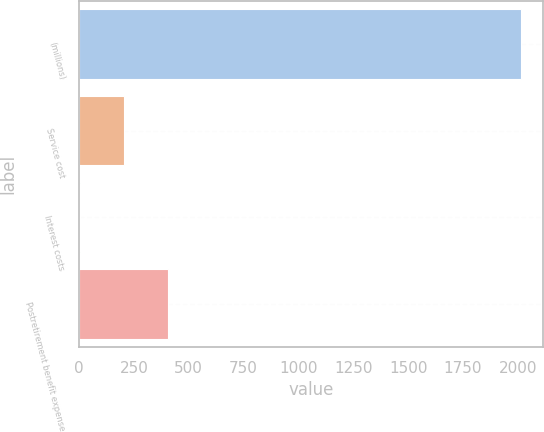<chart> <loc_0><loc_0><loc_500><loc_500><bar_chart><fcel>(millions)<fcel>Service cost<fcel>Interest costs<fcel>Postretirement benefit expense<nl><fcel>2013<fcel>204.99<fcel>4.1<fcel>405.88<nl></chart> 